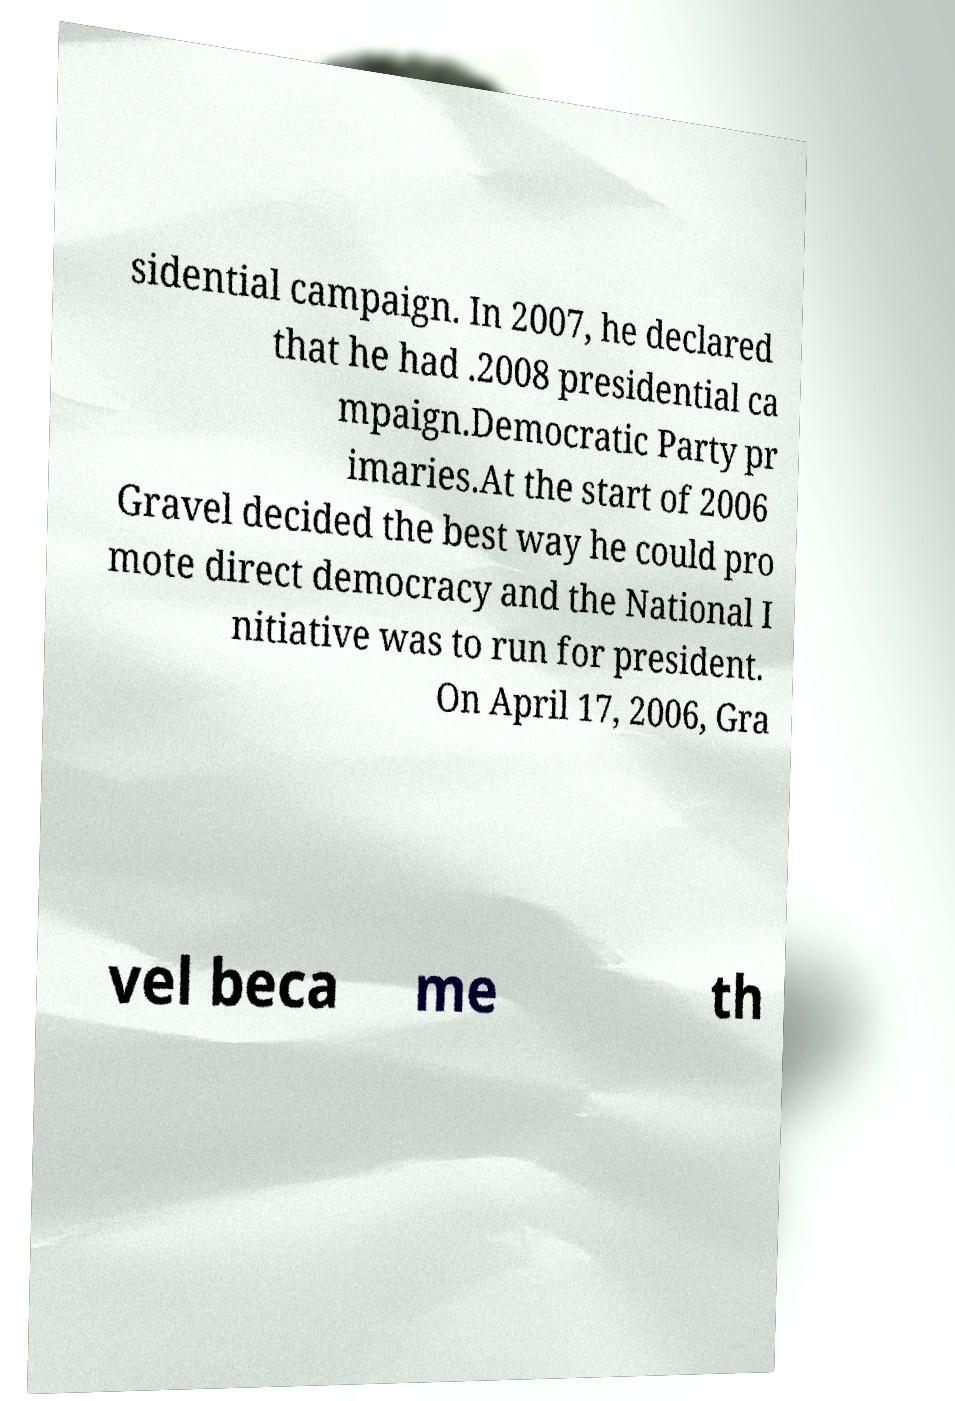Can you accurately transcribe the text from the provided image for me? sidential campaign. In 2007, he declared that he had .2008 presidential ca mpaign.Democratic Party pr imaries.At the start of 2006 Gravel decided the best way he could pro mote direct democracy and the National I nitiative was to run for president. On April 17, 2006, Gra vel beca me th 